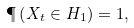Convert formula to latex. <formula><loc_0><loc_0><loc_500><loc_500>\P \left ( X _ { t } \in H _ { 1 } \right ) = 1 ,</formula> 